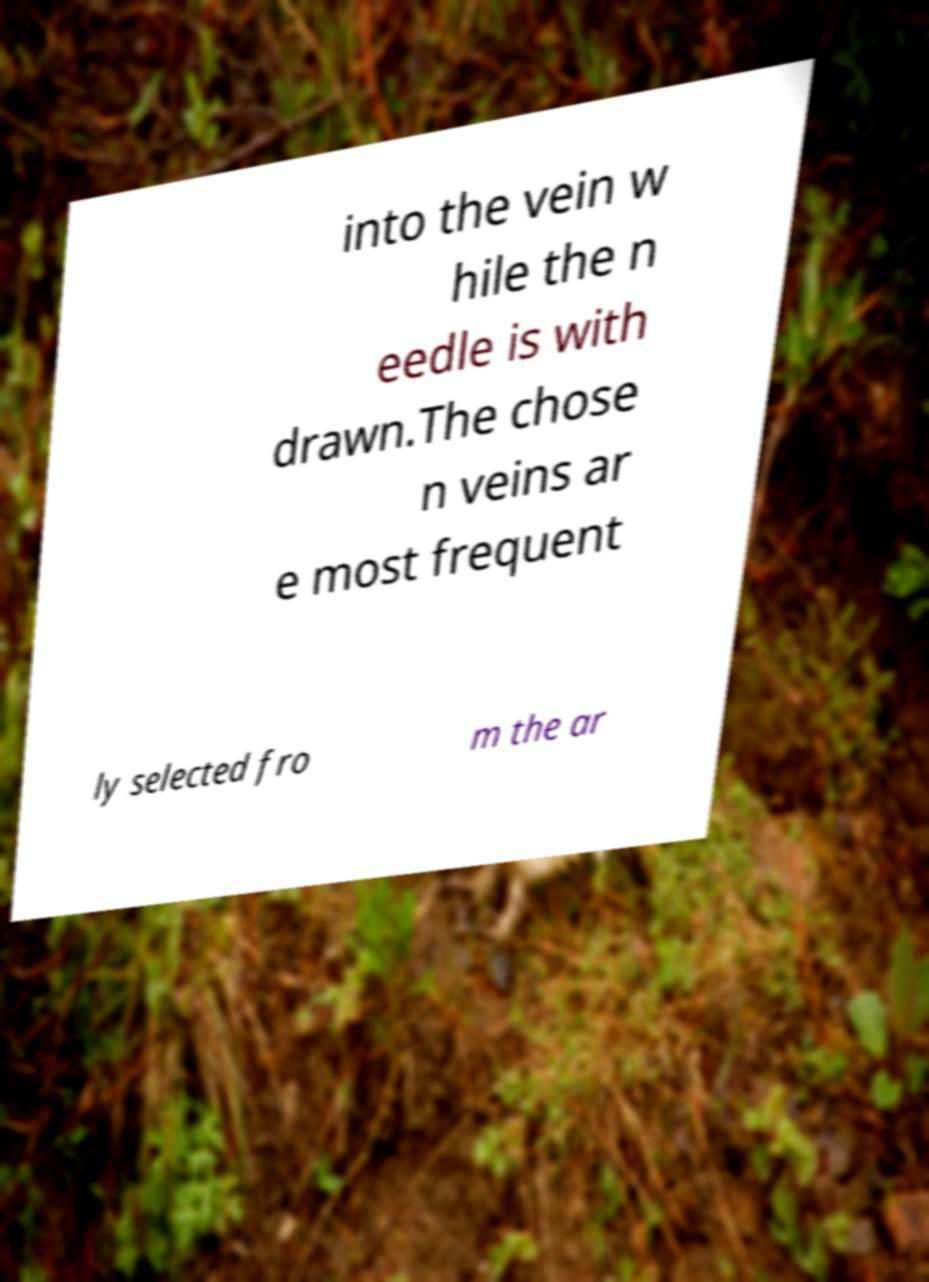There's text embedded in this image that I need extracted. Can you transcribe it verbatim? into the vein w hile the n eedle is with drawn.The chose n veins ar e most frequent ly selected fro m the ar 